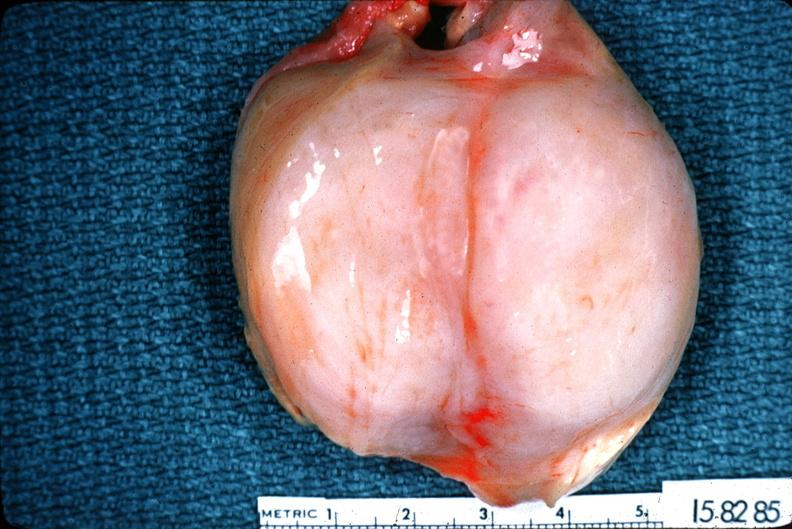does atheromatous embolus show schwannoma?
Answer the question using a single word or phrase. No 